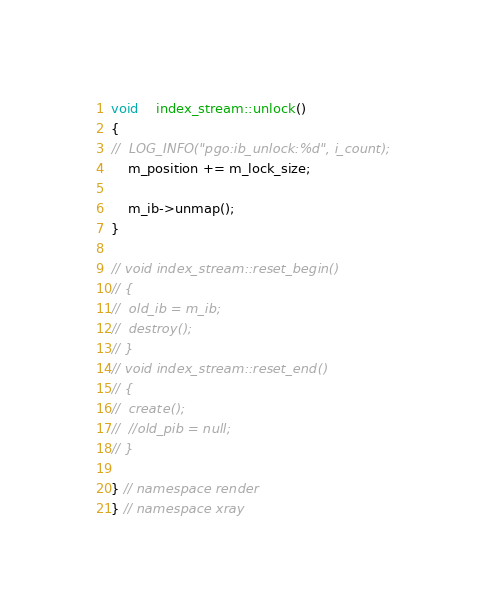Convert code to text. <code><loc_0><loc_0><loc_500><loc_500><_C++_>void	index_stream::unlock()
{
//	LOG_INFO("pgo:ib_unlock:%d", i_count);
	m_position += m_lock_size;

	m_ib->unmap();
}

// void index_stream::reset_begin()
// {
// 	old_ib = m_ib;
// 	destroy();
// }
// void index_stream::reset_end()
// {
// 	create();
// 	//old_pib = null;
// }

} // namespace render
} // namespace xray

</code> 